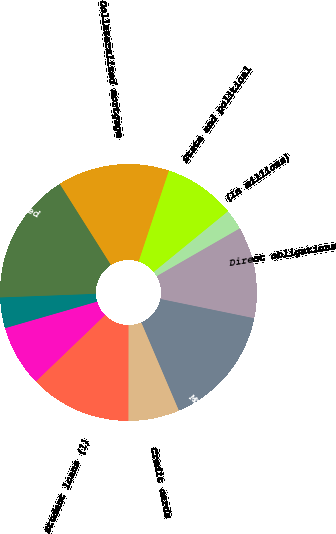Convert chart to OTSL. <chart><loc_0><loc_0><loc_500><loc_500><pie_chart><fcel>(In millions)<fcel>Direct obligations<fcel>Mortgage-backed securities<fcel>Credit cards<fcel>Student loans (1)<fcel>Sub-prime<fcel>Other<fcel>Total asset-backed<fcel>Collateralized mortgage<fcel>State and political<nl><fcel>2.6%<fcel>11.53%<fcel>15.36%<fcel>6.43%<fcel>12.81%<fcel>7.7%<fcel>3.87%<fcel>16.64%<fcel>14.08%<fcel>8.98%<nl></chart> 